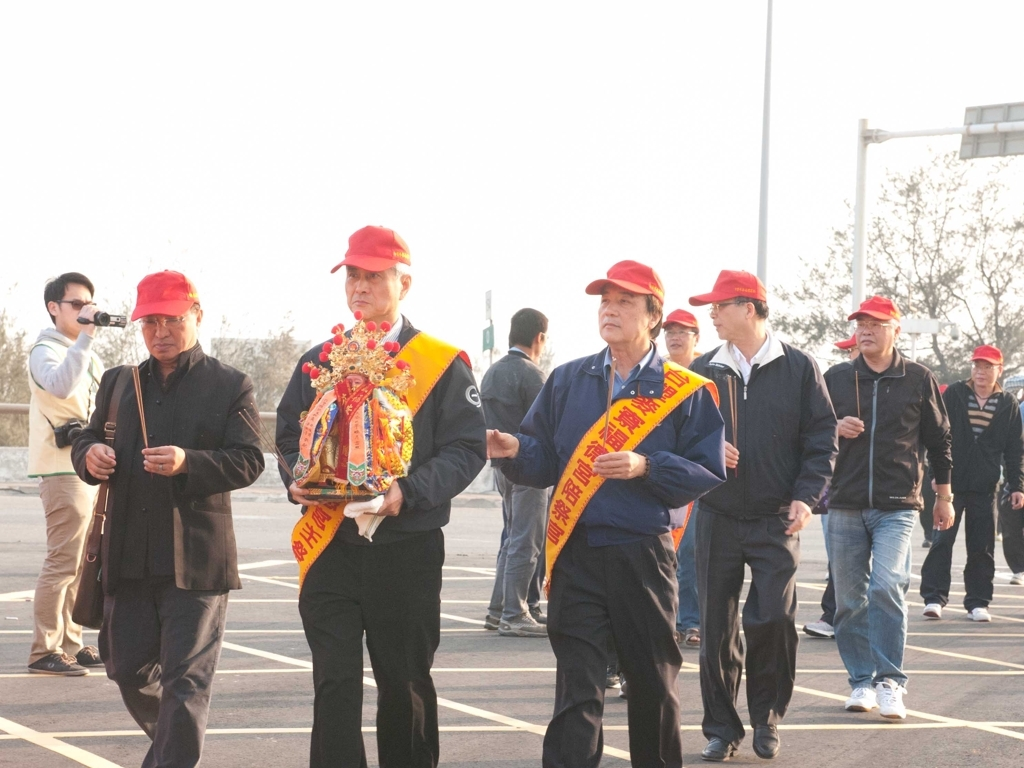Inspect the image closely and offer an evaluation rooted in your analysis. The image presents a group of individuals participating in what appears to be a cultural or ceremonial event, given the attire and the objects they carry, such as banners with inscriptions and traditional decorations. The composition and lighting conditions suggest this event takes place outdoors during daytime. Despite the slight overexposure and soft focus affecting the finer details, the image successfully captures the essence of the event and provides a glimpse into the cultural practices being showcased. 